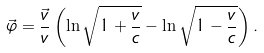Convert formula to latex. <formula><loc_0><loc_0><loc_500><loc_500>\vec { \varphi } = \frac { \vec { v } } { v } \left ( \ln \sqrt { 1 + \frac { v } { c } } - \ln \sqrt { 1 - \frac { v } { c } } \right ) .</formula> 